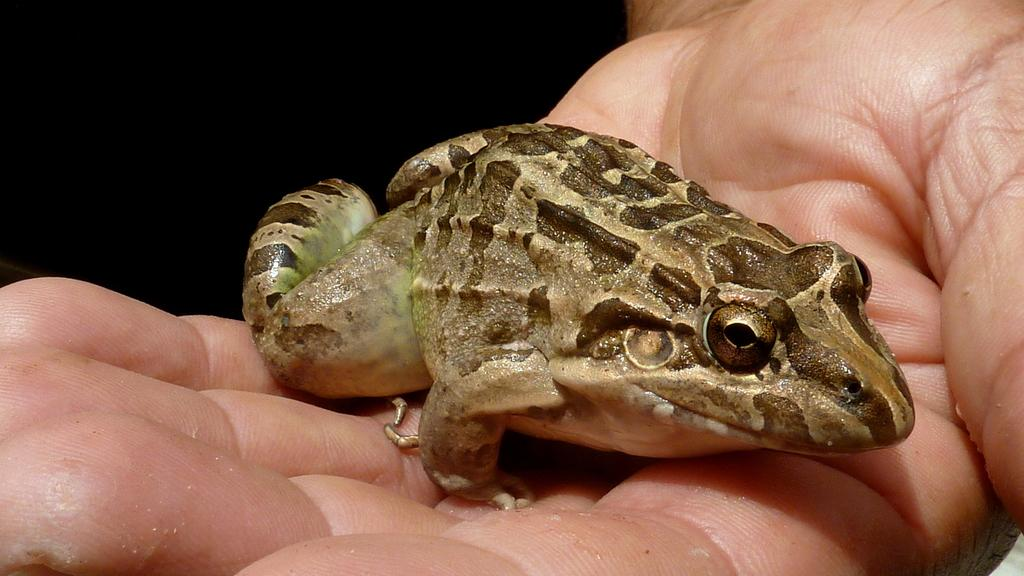What is on the hand in the image? There is a frog on the hand in the image. Can you describe the frog's appearance? The frog is cream, brown, and green in color. What is the color of the background in the image? The background of the image is dark. What type of produce is being sold on the sofa in the image? There is no sofa or produce present in the image; it features a hand with a frog on it against a dark background. 